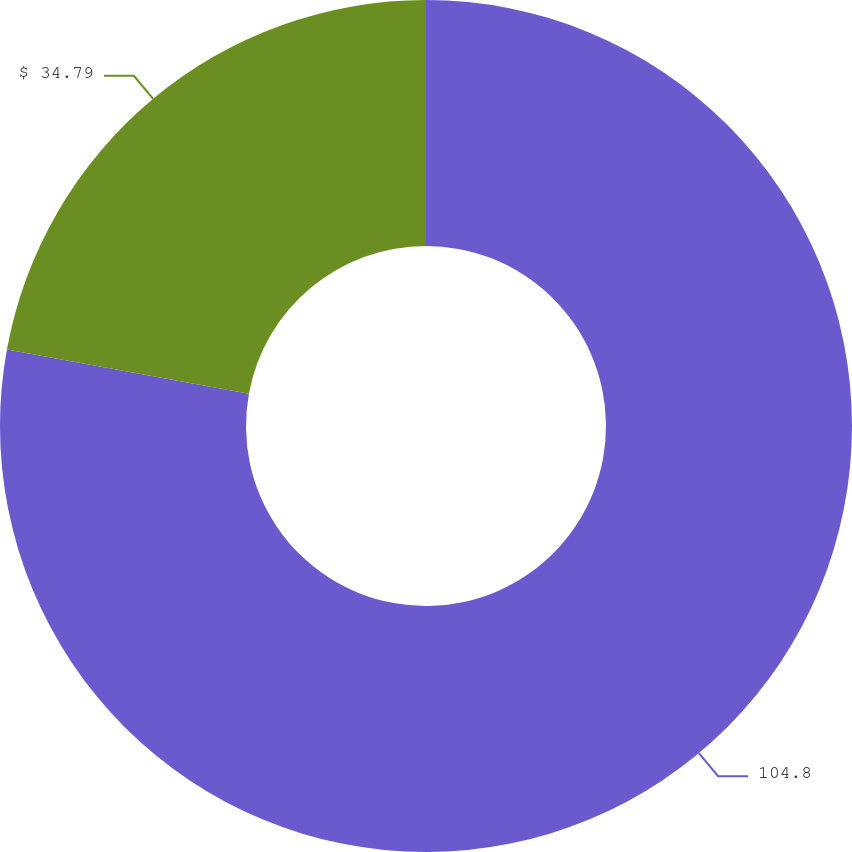Convert chart. <chart><loc_0><loc_0><loc_500><loc_500><pie_chart><fcel>104.8<fcel>$ 34.79<nl><fcel>77.87%<fcel>22.13%<nl></chart> 